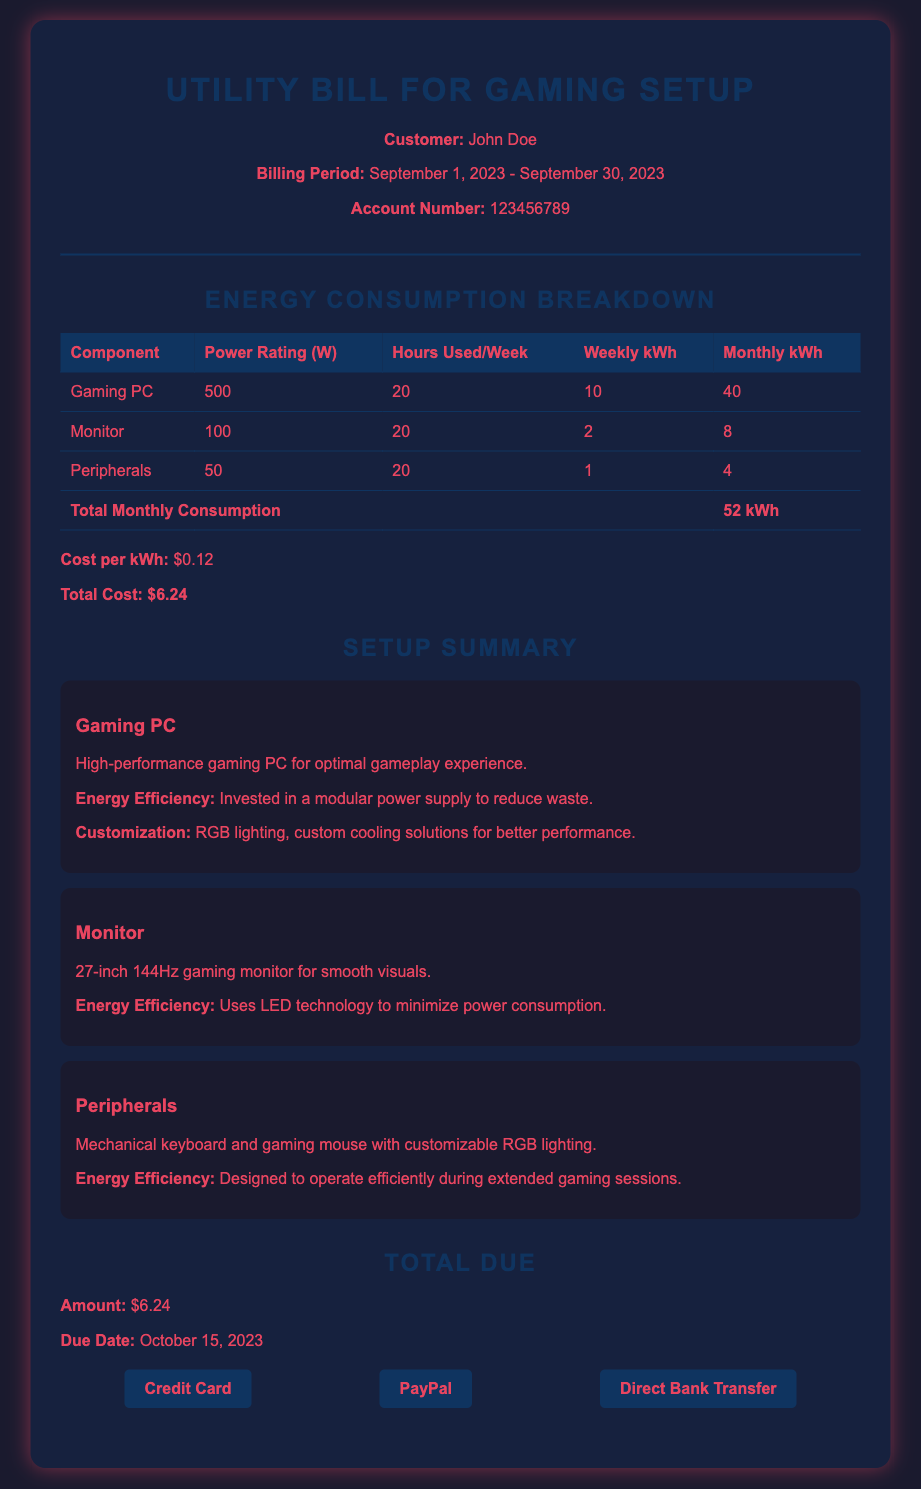What is the account number? The account number is specified in the document under the customer details.
Answer: 123456789 What is the billing period? The billing period is provided in the header section of the document.
Answer: September 1, 2023 - September 30, 2023 What is the total monthly consumption? The total monthly consumption is calculated from the breakdown of energy costs.
Answer: 52 kWh What is the cost per kWh? This information specifies the rate at which energy consumption is billed, mentioned in the breakdown.
Answer: $0.12 How much is the total cost? The total cost is derived from the total monthly consumption multiplied by the cost per kWh.
Answer: $6.24 When is the due date? The due date for the payment is listed in the total due section of the document.
Answer: October 15, 2023 What is one of the energy efficiency features of the gaming PC? This feature is mentioned in the setup summary for the gaming PC.
Answer: Modular power supply Which payment methods are available? The payment methods are listed at the bottom of the document under the total due section.
Answer: Credit Card, PayPal, Direct Bank Transfer What type of monitor is mentioned in the summary? The type of monitor is described in the setup summary section of the document.
Answer: 27-inch 144Hz gaming monitor 